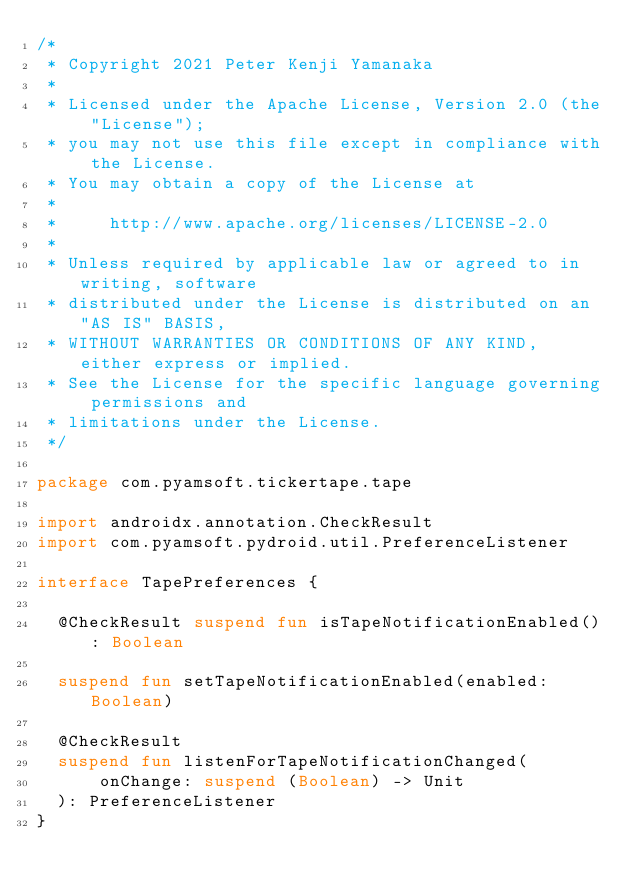<code> <loc_0><loc_0><loc_500><loc_500><_Kotlin_>/*
 * Copyright 2021 Peter Kenji Yamanaka
 *
 * Licensed under the Apache License, Version 2.0 (the "License");
 * you may not use this file except in compliance with the License.
 * You may obtain a copy of the License at
 *
 *     http://www.apache.org/licenses/LICENSE-2.0
 *
 * Unless required by applicable law or agreed to in writing, software
 * distributed under the License is distributed on an "AS IS" BASIS,
 * WITHOUT WARRANTIES OR CONDITIONS OF ANY KIND, either express or implied.
 * See the License for the specific language governing permissions and
 * limitations under the License.
 */

package com.pyamsoft.tickertape.tape

import androidx.annotation.CheckResult
import com.pyamsoft.pydroid.util.PreferenceListener

interface TapePreferences {

  @CheckResult suspend fun isTapeNotificationEnabled(): Boolean

  suspend fun setTapeNotificationEnabled(enabled: Boolean)

  @CheckResult
  suspend fun listenForTapeNotificationChanged(
      onChange: suspend (Boolean) -> Unit
  ): PreferenceListener
}
</code> 